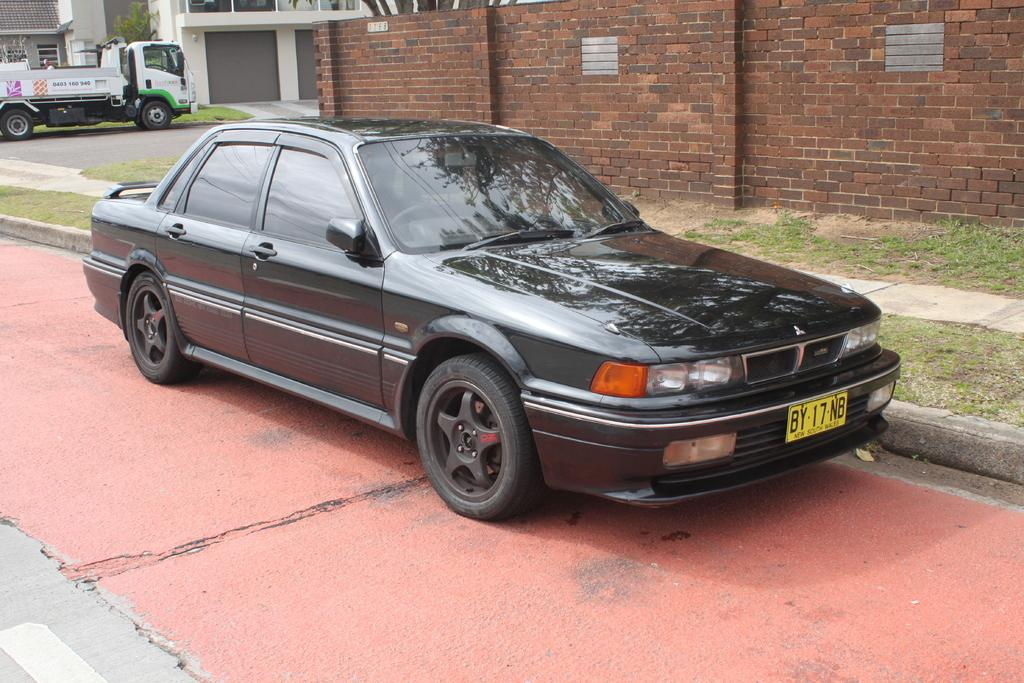What types of objects can be seen in the image? There are vehicles, grass, a path, a road, a brick wall, trees, and buildings in the image. Can you describe the landscape in the image? The image features a grassy area with a path, trees, and a brick wall, as well as a road and buildings. What might be the purpose of the path in the image? The path in the image could be used for walking or biking. How many types of structures are visible in the image? There are two types of structures visible in the image: a brick wall and buildings. What type of cord is being used to write the story in the image? There is no cord or story present in the image; it features vehicles, grass, a path, a road, a brick wall, trees, and buildings. 